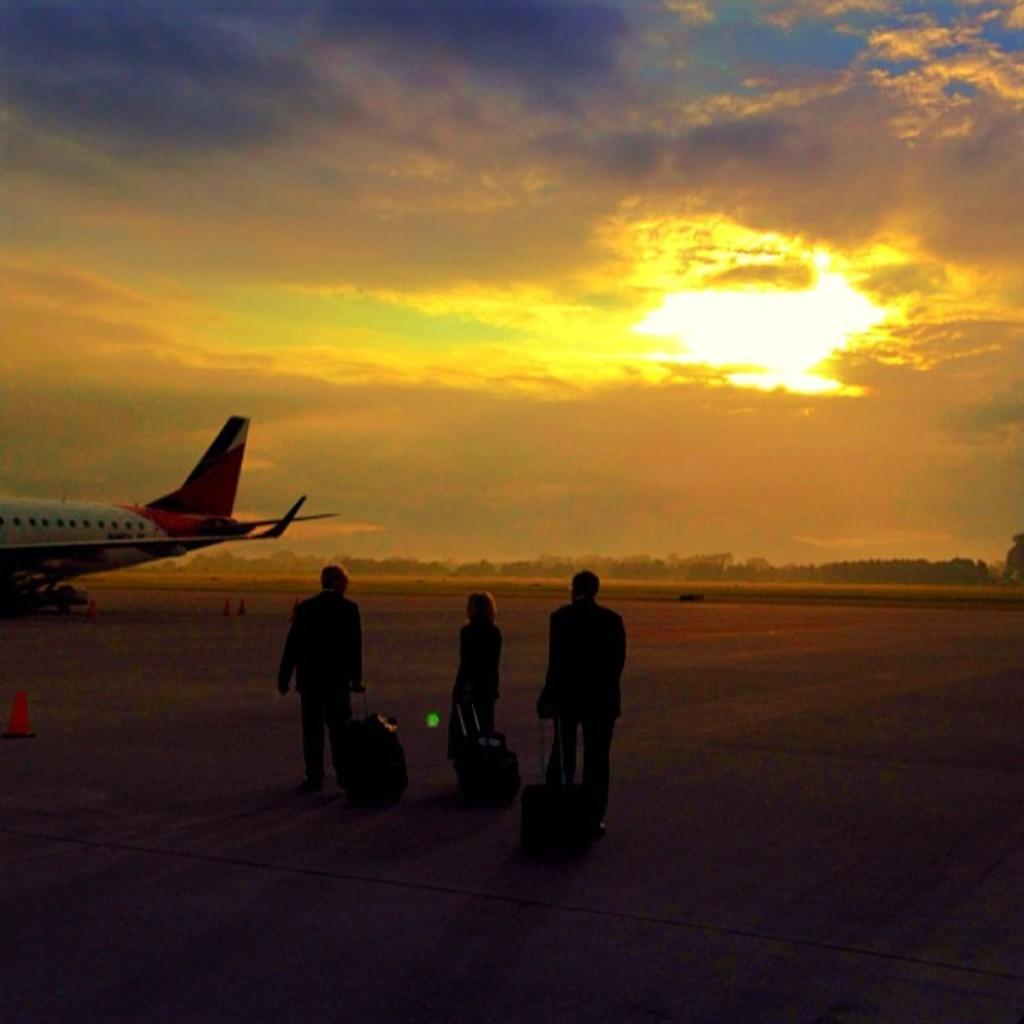What are the persons in the image doing? The persons in the image are walking on the road. What are the persons holding while walking on the road? The persons are holding suitcases. What objects can be seen on the road in the image? There are traffic cones in the image. What is visible in the background of the image? There is an airplane, trees, and the sky visible in the image. What is the condition of the sky in the image? The sky is visible with clouds present in the image. What type of decision can be seen being made by the feather in the image? There is no feather present in the image, so no decision can be made by a feather. 